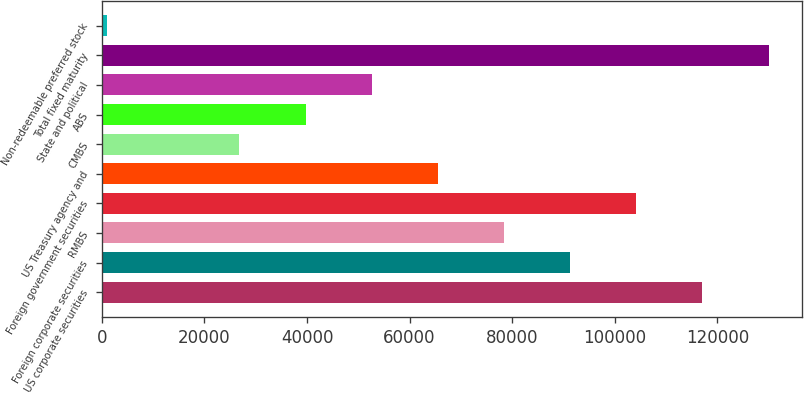Convert chart to OTSL. <chart><loc_0><loc_0><loc_500><loc_500><bar_chart><fcel>US corporate securities<fcel>Foreign corporate securities<fcel>RMBS<fcel>Foreign government securities<fcel>US Treasury agency and<fcel>CMBS<fcel>ABS<fcel>State and political<fcel>Total fixed maturity<fcel>Non-redeemable preferred stock<nl><fcel>117100<fcel>91303.1<fcel>78404.8<fcel>104201<fcel>65506.5<fcel>26811.6<fcel>39709.9<fcel>52608.2<fcel>129998<fcel>1015<nl></chart> 